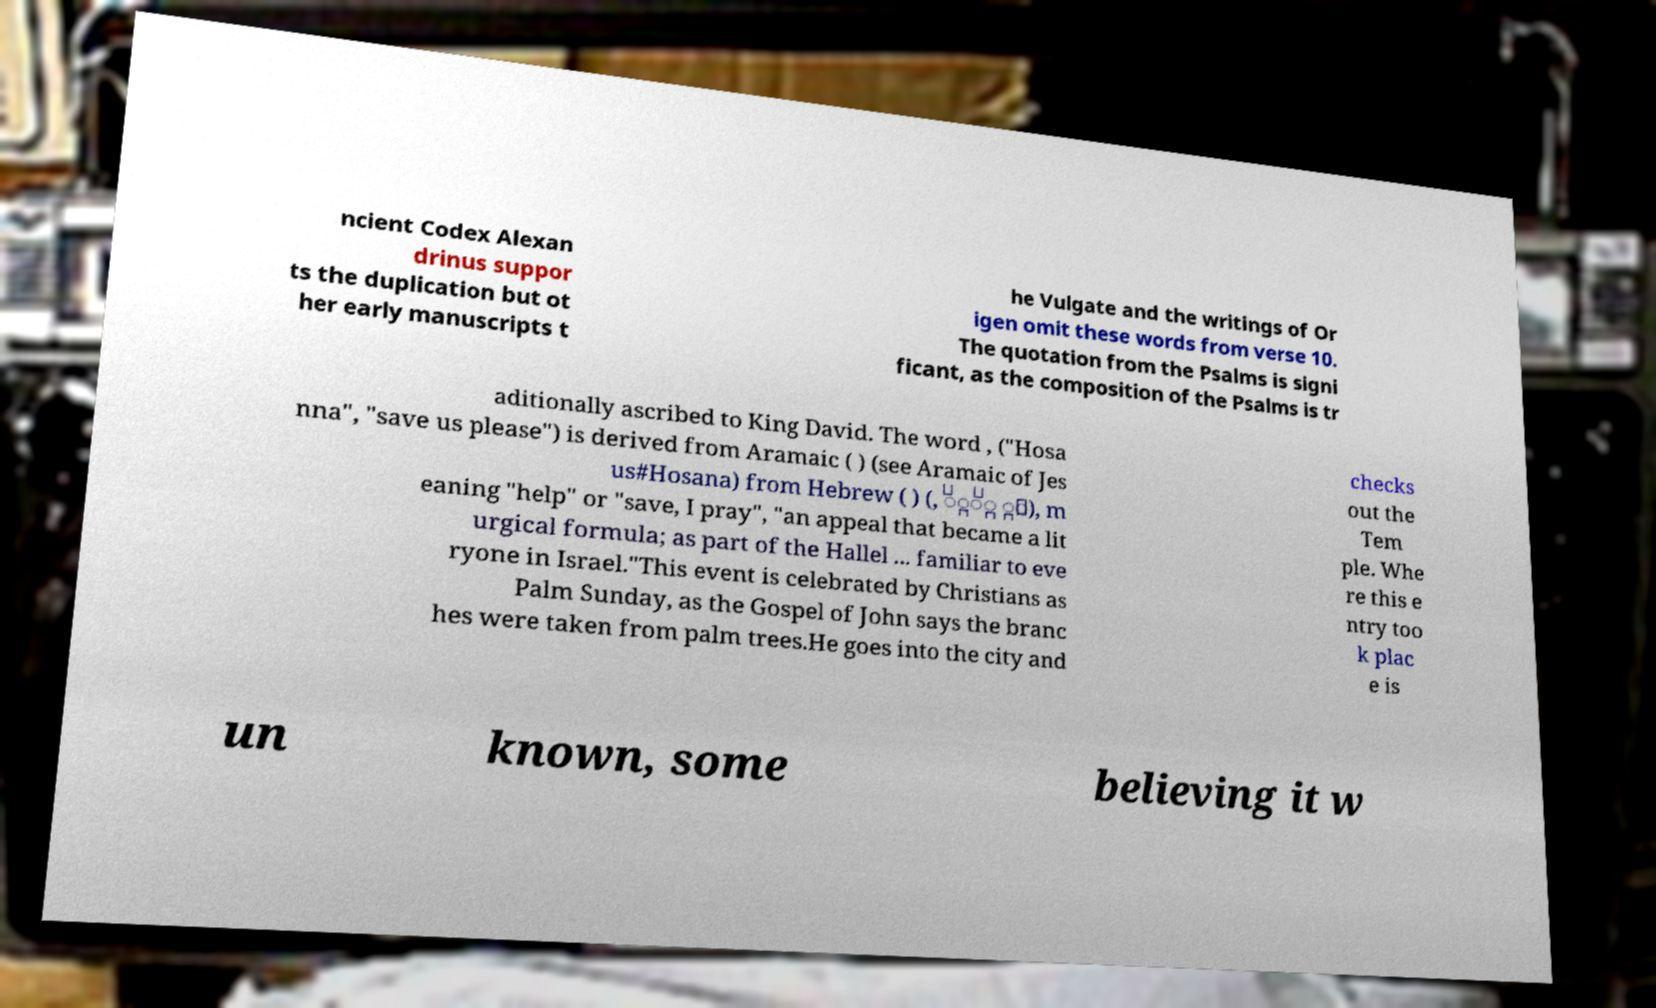Please read and relay the text visible in this image. What does it say? ncient Codex Alexan drinus suppor ts the duplication but ot her early manuscripts t he Vulgate and the writings of Or igen omit these words from verse 10. The quotation from the Psalms is signi ficant, as the composition of the Psalms is tr aditionally ascribed to King David. The word , ("Hosa nna", "save us please") is derived from Aramaic ( ) (see Aramaic of Jes us#Hosana) from Hebrew ( ) (, ִָֹׁ ָּ), m eaning "help" or "save, I pray", "an appeal that became a lit urgical formula; as part of the Hallel ... familiar to eve ryone in Israel."This event is celebrated by Christians as Palm Sunday, as the Gospel of John says the branc hes were taken from palm trees.He goes into the city and checks out the Tem ple. Whe re this e ntry too k plac e is un known, some believing it w 